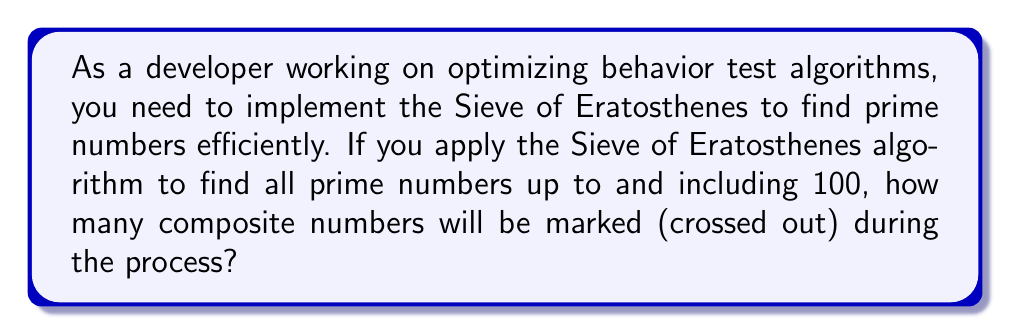Can you answer this question? To solve this problem, let's walk through the Sieve of Eratosthenes algorithm step by step:

1) First, create a list of all integers from 2 to 100.

2) Start with the first prime number, 2. Mark all its multiples (except itself) as composite:
   4, 6, 8, 10, ..., 98, 100
   This marks 49 numbers.

3) The next unmarked number is 3, which is prime. Mark all its multiples (except itself) that haven't been marked yet:
   9, 15, 21, 27, ..., 99
   This marks 33 new numbers.

4) The next unmarked number is 5. Mark its unmarked multiples:
   25, 35, 55, 65, 85, 95
   This marks 6 new numbers.

5) The next unmarked number is 7. Mark its unmarked multiples:
   49, 77
   This marks 2 new numbers.

6) The next unmarked number is 11, but $11^2 = 121 > 100$, so we can stop here.

To count the total number of composite numbers marked, we sum up the numbers marked at each step:

$$ 49 + 33 + 6 + 2 = 90 $$

We can verify this result by counting the prime numbers up to 100, which are:
2, 3, 5, 7, 11, 13, 17, 19, 23, 29, 31, 37, 41, 43, 47, 53, 59, 61, 67, 71, 73, 79, 83, 89, 97

There are 25 prime numbers in this list. Since there are 99 numbers from 2 to 100, and 25 of them are prime, the remaining 74 must be composite.

The difference between our count (90) and the actual number of composites (74) is due to some composites being marked multiple times in the sieving process.
Answer: 90 composite numbers will be marked during the Sieve of Eratosthenes process for numbers up to 100. 